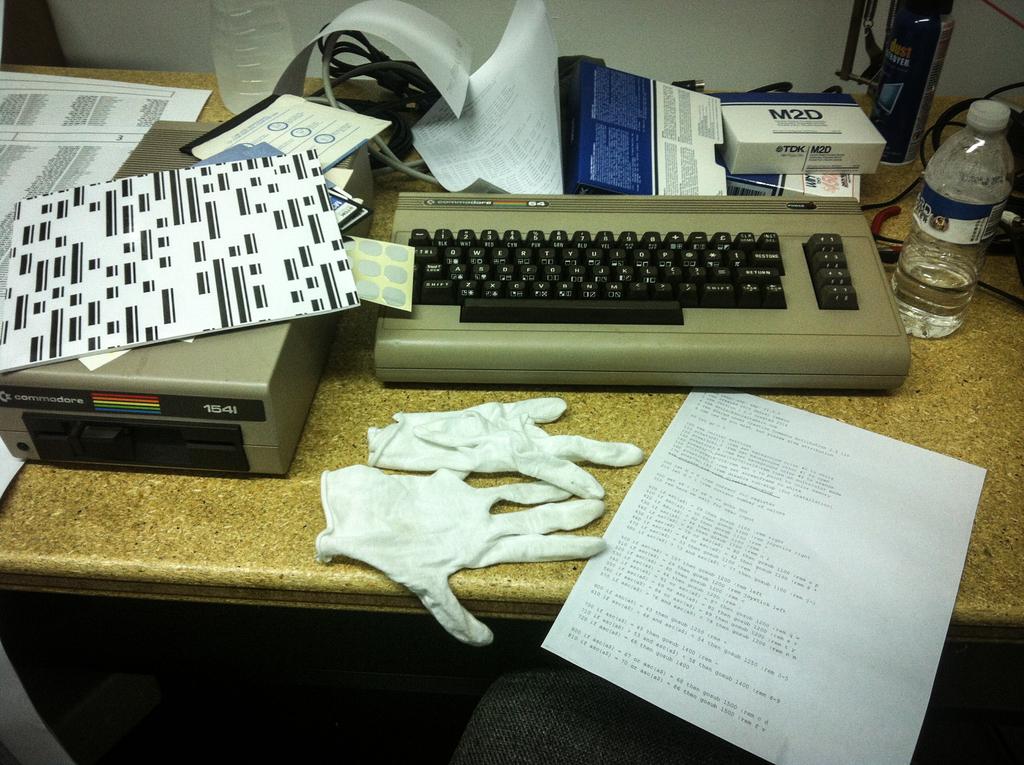What is that a box of?
Your response must be concise. M2d. Is that a 1541 floppy drive in the bottom left?
Keep it short and to the point. Yes. 